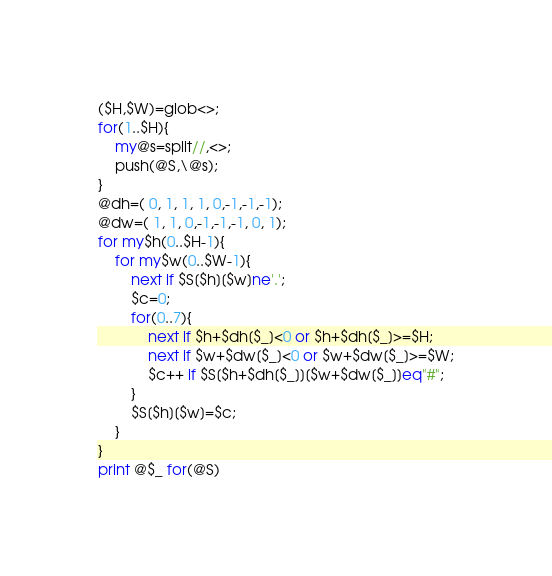Convert code to text. <code><loc_0><loc_0><loc_500><loc_500><_Perl_>($H,$W)=glob<>;
for(1..$H){
    my@s=split//,<>;
    push(@S,\@s);
}
@dh=( 0, 1, 1, 1, 0,-1,-1,-1);
@dw=( 1, 1, 0,-1,-1,-1, 0, 1);
for my$h(0..$H-1){
    for my$w(0..$W-1){
        next if $S[$h][$w]ne'.';
        $c=0;
        for(0..7){
            next if $h+$dh[$_]<0 or $h+$dh[$_]>=$H;
            next if $w+$dw[$_]<0 or $w+$dw[$_]>=$W;
            $c++ if $S[$h+$dh[$_]][$w+$dw[$_]]eq"#";
        }
        $S[$h][$w]=$c;
    }
}
print @$_ for(@S)</code> 